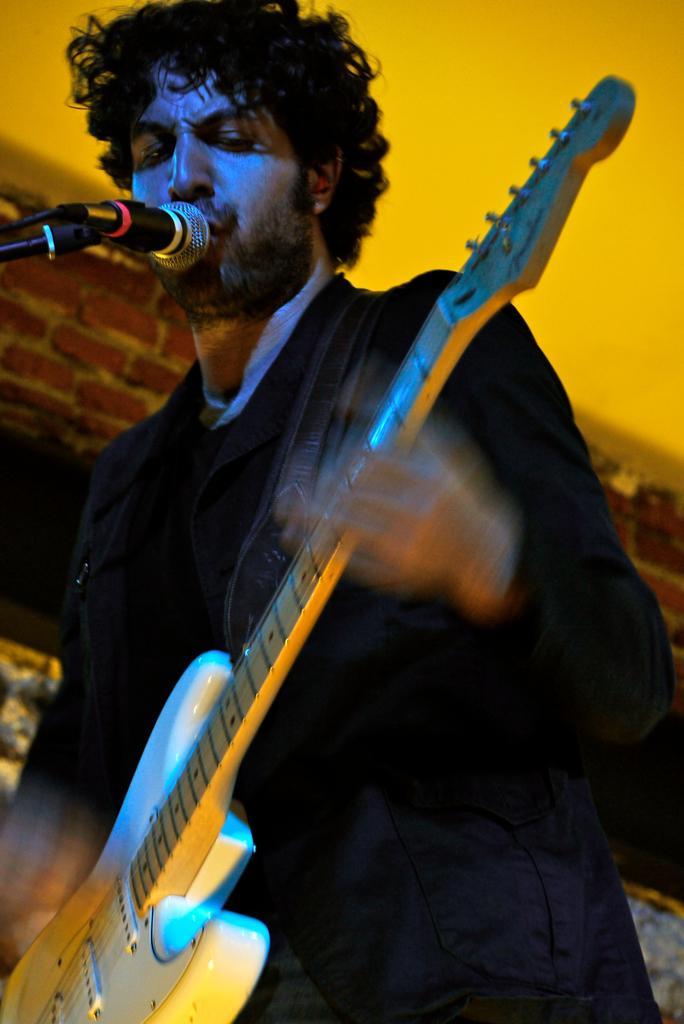Could you give a brief overview of what you see in this image? In this image person is standing by holding the guitar. In front of him there is a mike. At the background there is wall. 